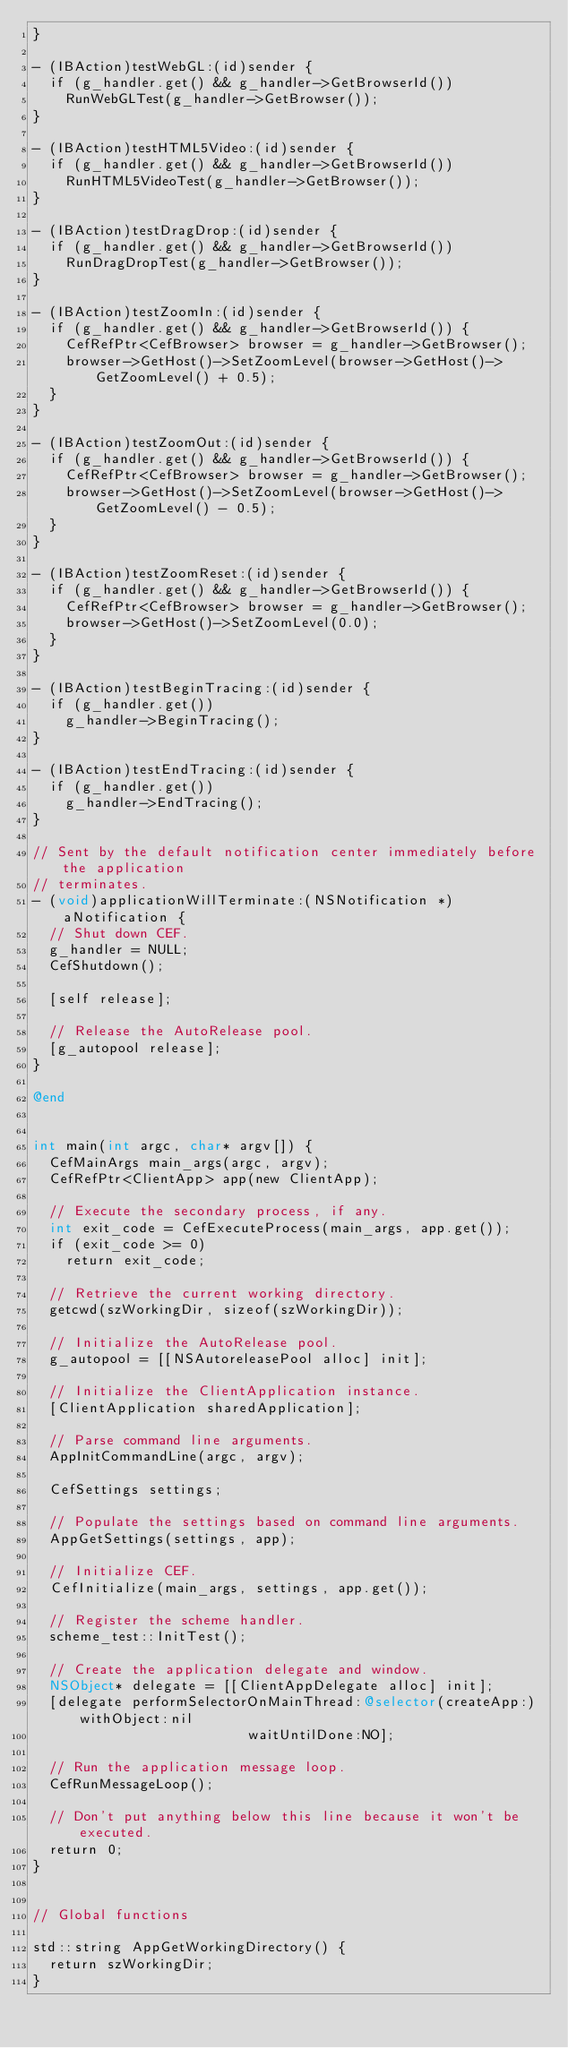<code> <loc_0><loc_0><loc_500><loc_500><_ObjectiveC_>}

- (IBAction)testWebGL:(id)sender {
  if (g_handler.get() && g_handler->GetBrowserId())
    RunWebGLTest(g_handler->GetBrowser());
}

- (IBAction)testHTML5Video:(id)sender {
  if (g_handler.get() && g_handler->GetBrowserId())
    RunHTML5VideoTest(g_handler->GetBrowser());
}

- (IBAction)testDragDrop:(id)sender {
  if (g_handler.get() && g_handler->GetBrowserId())
    RunDragDropTest(g_handler->GetBrowser());
}

- (IBAction)testZoomIn:(id)sender {
  if (g_handler.get() && g_handler->GetBrowserId()) {
    CefRefPtr<CefBrowser> browser = g_handler->GetBrowser();
    browser->GetHost()->SetZoomLevel(browser->GetHost()->GetZoomLevel() + 0.5);
  }
}

- (IBAction)testZoomOut:(id)sender {
  if (g_handler.get() && g_handler->GetBrowserId()) {
    CefRefPtr<CefBrowser> browser = g_handler->GetBrowser();
    browser->GetHost()->SetZoomLevel(browser->GetHost()->GetZoomLevel() - 0.5);
  }
}

- (IBAction)testZoomReset:(id)sender {
  if (g_handler.get() && g_handler->GetBrowserId()) {
    CefRefPtr<CefBrowser> browser = g_handler->GetBrowser();
    browser->GetHost()->SetZoomLevel(0.0);
  }
}

- (IBAction)testBeginTracing:(id)sender {
  if (g_handler.get())
    g_handler->BeginTracing();
}

- (IBAction)testEndTracing:(id)sender {
  if (g_handler.get())
    g_handler->EndTracing();
}

// Sent by the default notification center immediately before the application
// terminates.
- (void)applicationWillTerminate:(NSNotification *)aNotification {
  // Shut down CEF.
  g_handler = NULL;
  CefShutdown();

  [self release];

  // Release the AutoRelease pool.
  [g_autopool release];
}

@end


int main(int argc, char* argv[]) {
  CefMainArgs main_args(argc, argv);
  CefRefPtr<ClientApp> app(new ClientApp);

  // Execute the secondary process, if any.
  int exit_code = CefExecuteProcess(main_args, app.get());
  if (exit_code >= 0)
    return exit_code;

  // Retrieve the current working directory.
  getcwd(szWorkingDir, sizeof(szWorkingDir));

  // Initialize the AutoRelease pool.
  g_autopool = [[NSAutoreleasePool alloc] init];

  // Initialize the ClientApplication instance.
  [ClientApplication sharedApplication];
  
  // Parse command line arguments.
  AppInitCommandLine(argc, argv);

  CefSettings settings;

  // Populate the settings based on command line arguments.
  AppGetSettings(settings, app);

  // Initialize CEF.
  CefInitialize(main_args, settings, app.get());

  // Register the scheme handler.
  scheme_test::InitTest();

  // Create the application delegate and window.
  NSObject* delegate = [[ClientAppDelegate alloc] init];
  [delegate performSelectorOnMainThread:@selector(createApp:) withObject:nil
                          waitUntilDone:NO];

  // Run the application message loop.
  CefRunMessageLoop();

  // Don't put anything below this line because it won't be executed.
  return 0;
}


// Global functions

std::string AppGetWorkingDirectory() {
  return szWorkingDir;
}
</code> 